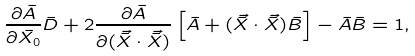Convert formula to latex. <formula><loc_0><loc_0><loc_500><loc_500>\frac { \partial { \bar { A } } } { \partial { \bar { X _ { 0 } } } } \bar { D } + 2 \frac { \partial { \bar { A } } } { \partial { ( \vec { \bar { X } } \cdot \vec { \bar { X } } ) } } \left [ \bar { A } + ( \vec { \bar { X } } \cdot \vec { \bar { X } } ) \bar { B } \right ] - \bar { A } \bar { B } = 1 ,</formula> 